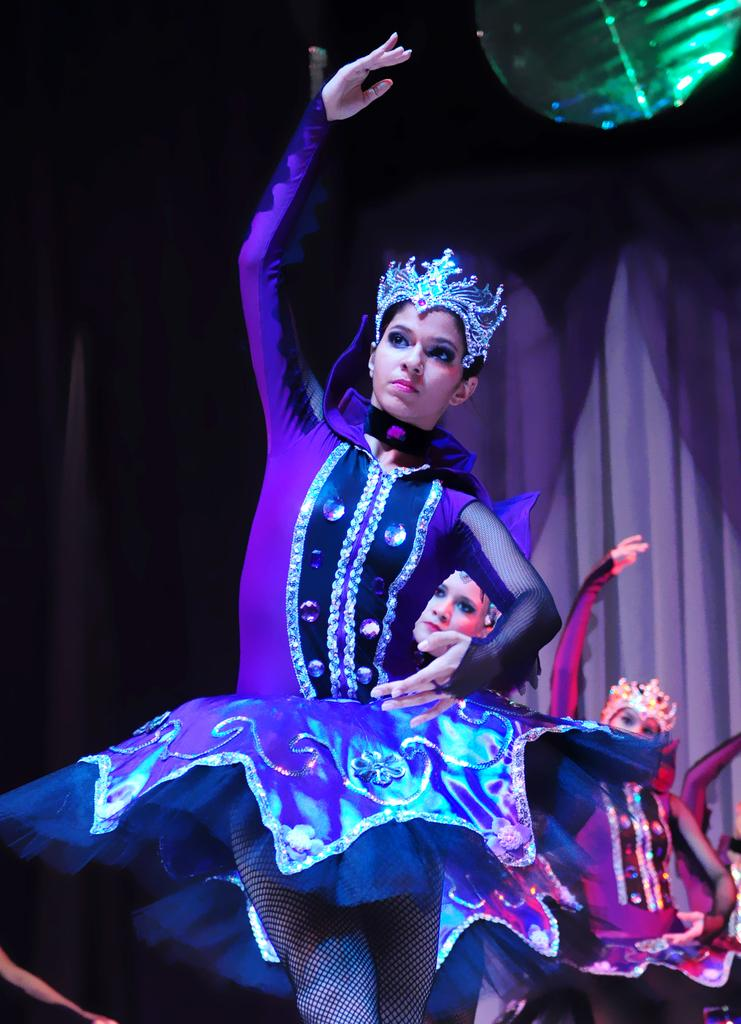Who is present in the image? There are women in the image. What are the women wearing? The women are wearing costumes. What are the women doing in the image? The women are dancing. What can be seen in the background of the image? There is a blue curtain in the background of the image. What verse is being recited by the women in the image? There is no indication in the image that the women are reciting a verse, as they are dancing and not speaking. 